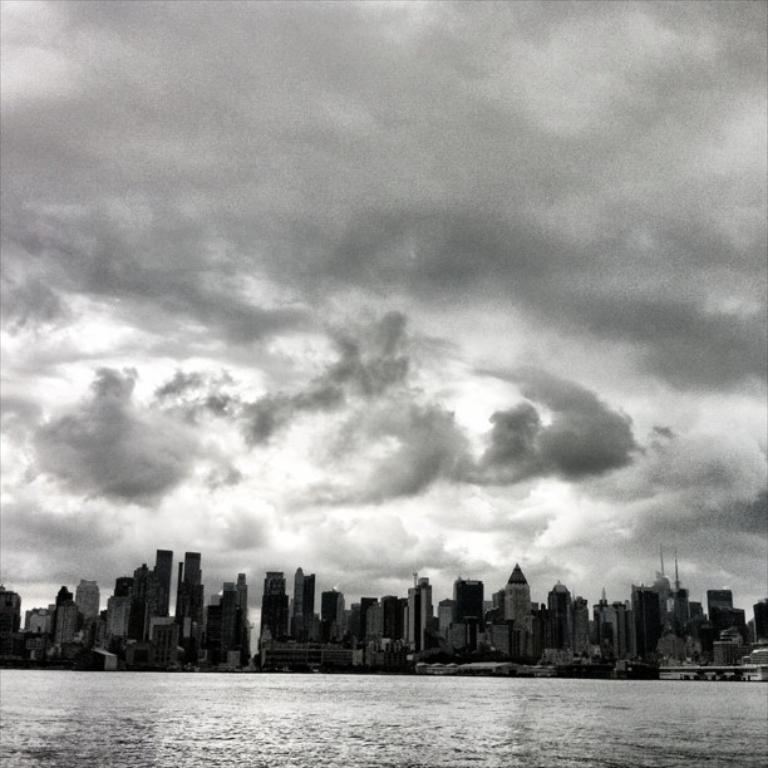What is the primary element visible in the image? There is water in the image. What can be seen in the distance behind the water? There are buildings in the background of the image. What part of the natural environment is visible in the image? The sky is visible in the image. How would you describe the weather based on the appearance of the sky? The sky appears to be cloudy. What is the color scheme of the image? The image is in black and white. How many mice can be seen playing on the sand in the image? There are no mice or sand present in the image. 